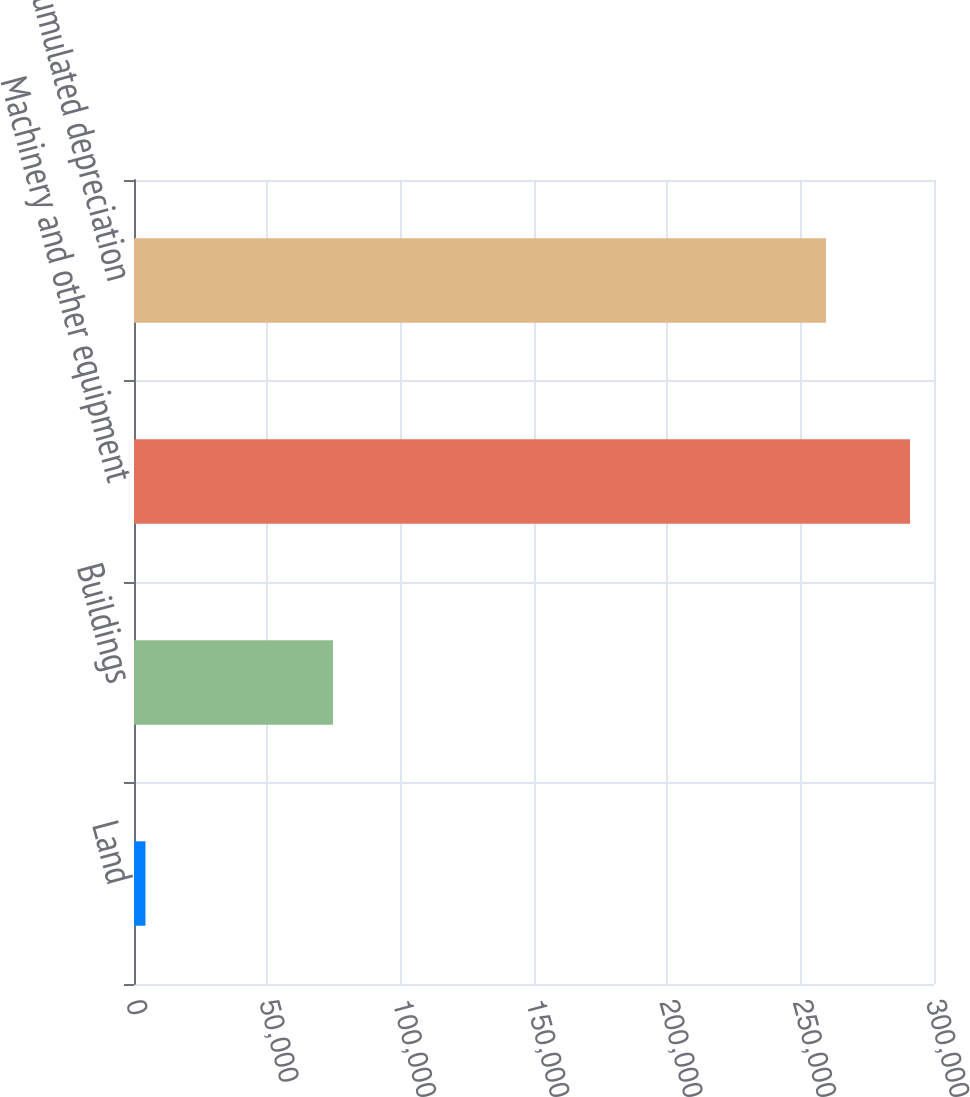Convert chart to OTSL. <chart><loc_0><loc_0><loc_500><loc_500><bar_chart><fcel>Land<fcel>Buildings<fcel>Machinery and other equipment<fcel>Accumulated depreciation<nl><fcel>4308<fcel>74609<fcel>291004<fcel>259524<nl></chart> 